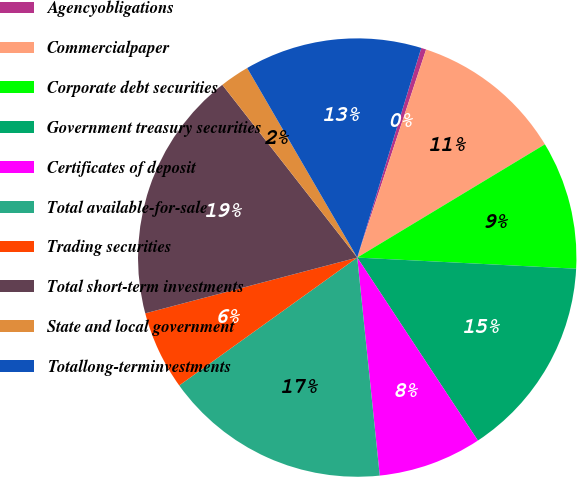<chart> <loc_0><loc_0><loc_500><loc_500><pie_chart><fcel>Agencyobligations<fcel>Commercialpaper<fcel>Corporate debt securities<fcel>Government treasury securities<fcel>Certificates of deposit<fcel>Total available-for-sale<fcel>Trading securities<fcel>Total short-term investments<fcel>State and local government<fcel>Totallong-terminvestments<nl><fcel>0.37%<fcel>11.27%<fcel>9.45%<fcel>14.91%<fcel>7.64%<fcel>16.72%<fcel>5.82%<fcel>18.54%<fcel>2.18%<fcel>13.09%<nl></chart> 